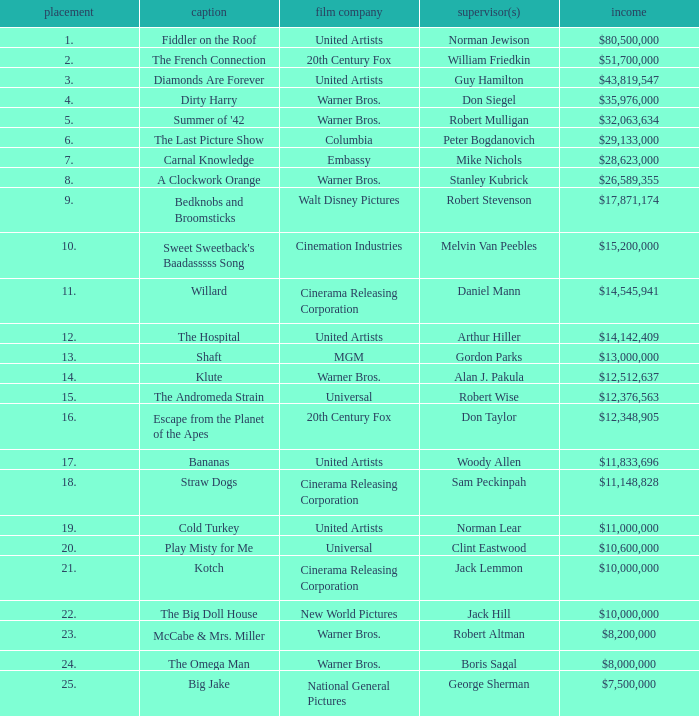Which title ranked lower than 19 has a gross of $11,833,696? Bananas. 